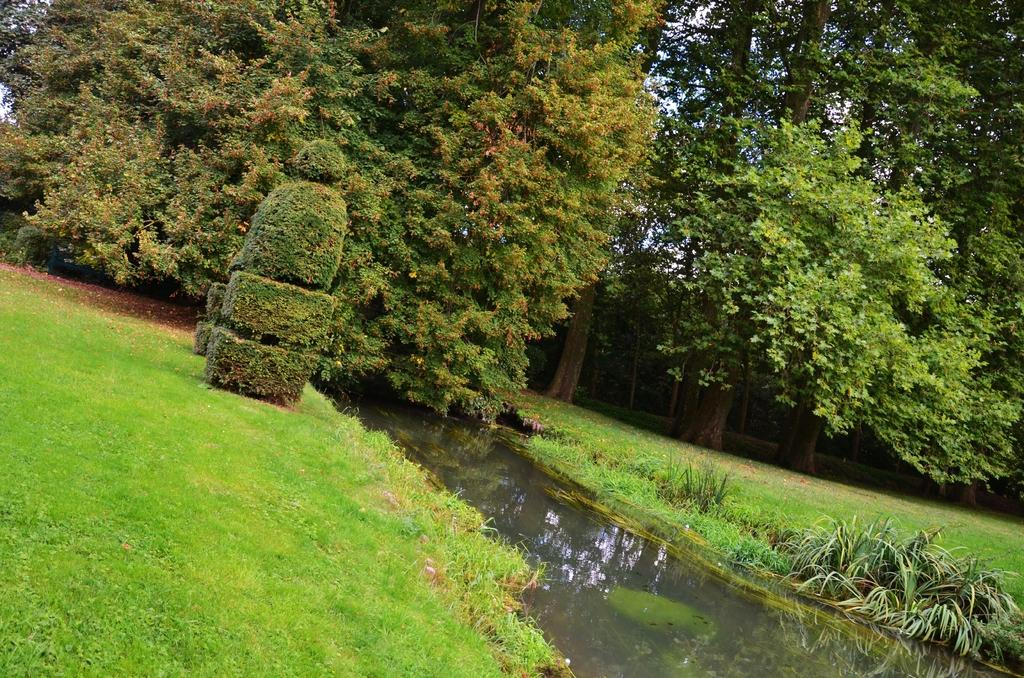What type of vegetation can be seen in the image? There is grass in the image. What else is visible besides the grass? There is water and trees visible in the image. What type of rice is being cooked in the image? There is no rice present in the image; it features grass, water, and trees. What part of the brain can be seen in the image? There is no brain present in the image; it features grass, water, and trees. 